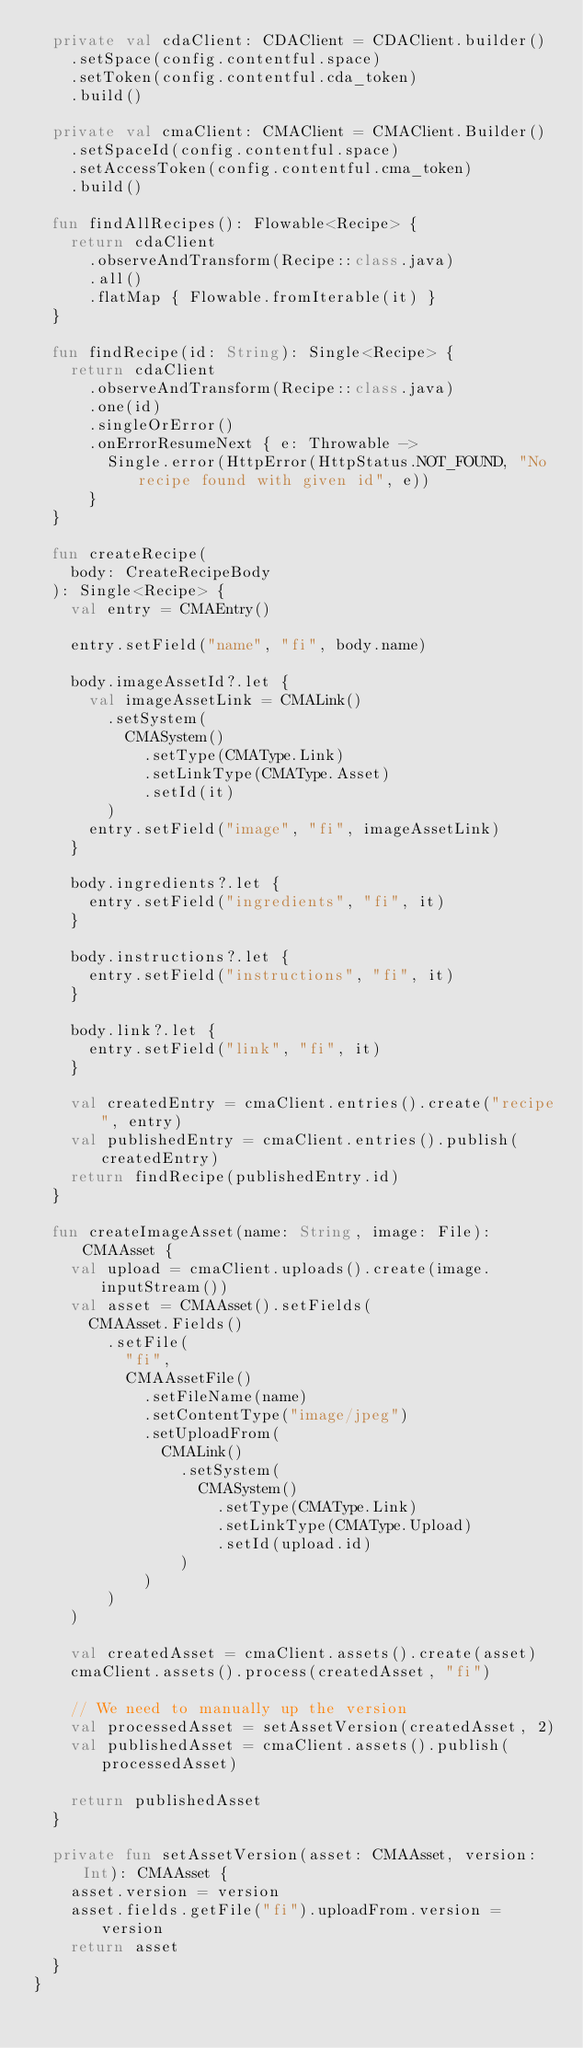<code> <loc_0><loc_0><loc_500><loc_500><_Kotlin_>  private val cdaClient: CDAClient = CDAClient.builder()
    .setSpace(config.contentful.space)
    .setToken(config.contentful.cda_token)
    .build()

  private val cmaClient: CMAClient = CMAClient.Builder()
    .setSpaceId(config.contentful.space)
    .setAccessToken(config.contentful.cma_token)
    .build()

  fun findAllRecipes(): Flowable<Recipe> {
    return cdaClient
      .observeAndTransform(Recipe::class.java)
      .all()
      .flatMap { Flowable.fromIterable(it) }
  }

  fun findRecipe(id: String): Single<Recipe> {
    return cdaClient
      .observeAndTransform(Recipe::class.java)
      .one(id)
      .singleOrError()
      .onErrorResumeNext { e: Throwable ->
        Single.error(HttpError(HttpStatus.NOT_FOUND, "No recipe found with given id", e))
      }
  }

  fun createRecipe(
    body: CreateRecipeBody
  ): Single<Recipe> {
    val entry = CMAEntry()

    entry.setField("name", "fi", body.name)

    body.imageAssetId?.let {
      val imageAssetLink = CMALink()
        .setSystem(
          CMASystem()
            .setType(CMAType.Link)
            .setLinkType(CMAType.Asset)
            .setId(it)
        )
      entry.setField("image", "fi", imageAssetLink)
    }

    body.ingredients?.let {
      entry.setField("ingredients", "fi", it)
    }

    body.instructions?.let {
      entry.setField("instructions", "fi", it)
    }

    body.link?.let {
      entry.setField("link", "fi", it)
    }

    val createdEntry = cmaClient.entries().create("recipe", entry)
    val publishedEntry = cmaClient.entries().publish(createdEntry)
    return findRecipe(publishedEntry.id)
  }

  fun createImageAsset(name: String, image: File): CMAAsset {
    val upload = cmaClient.uploads().create(image.inputStream())
    val asset = CMAAsset().setFields(
      CMAAsset.Fields()
        .setFile(
          "fi",
          CMAAssetFile()
            .setFileName(name)
            .setContentType("image/jpeg")
            .setUploadFrom(
              CMALink()
                .setSystem(
                  CMASystem()
                    .setType(CMAType.Link)
                    .setLinkType(CMAType.Upload)
                    .setId(upload.id)
                )
            )
        )
    )

    val createdAsset = cmaClient.assets().create(asset)
    cmaClient.assets().process(createdAsset, "fi")

    // We need to manually up the version
    val processedAsset = setAssetVersion(createdAsset, 2)
    val publishedAsset = cmaClient.assets().publish(processedAsset)

    return publishedAsset
  }

  private fun setAssetVersion(asset: CMAAsset, version: Int): CMAAsset {
    asset.version = version
    asset.fields.getFile("fi").uploadFrom.version = version
    return asset
  }
}
</code> 